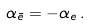Convert formula to latex. <formula><loc_0><loc_0><loc_500><loc_500>\alpha _ { \bar { e } } = - \alpha _ { e } \, .</formula> 